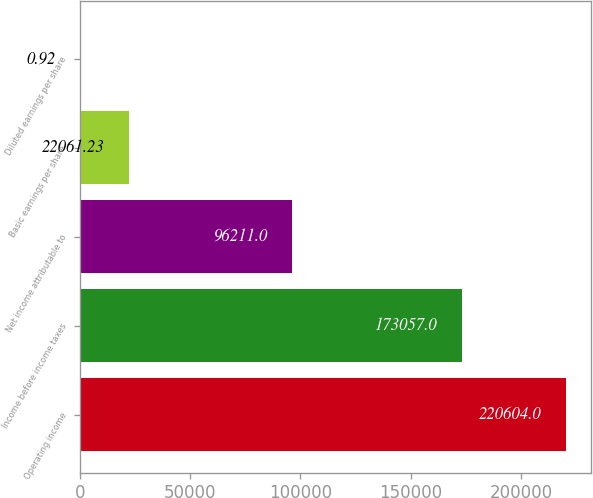Convert chart. <chart><loc_0><loc_0><loc_500><loc_500><bar_chart><fcel>Operating income<fcel>Income before income taxes<fcel>Net income attributable to<fcel>Basic earnings per share<fcel>Diluted earnings per share<nl><fcel>220604<fcel>173057<fcel>96211<fcel>22061.2<fcel>0.92<nl></chart> 